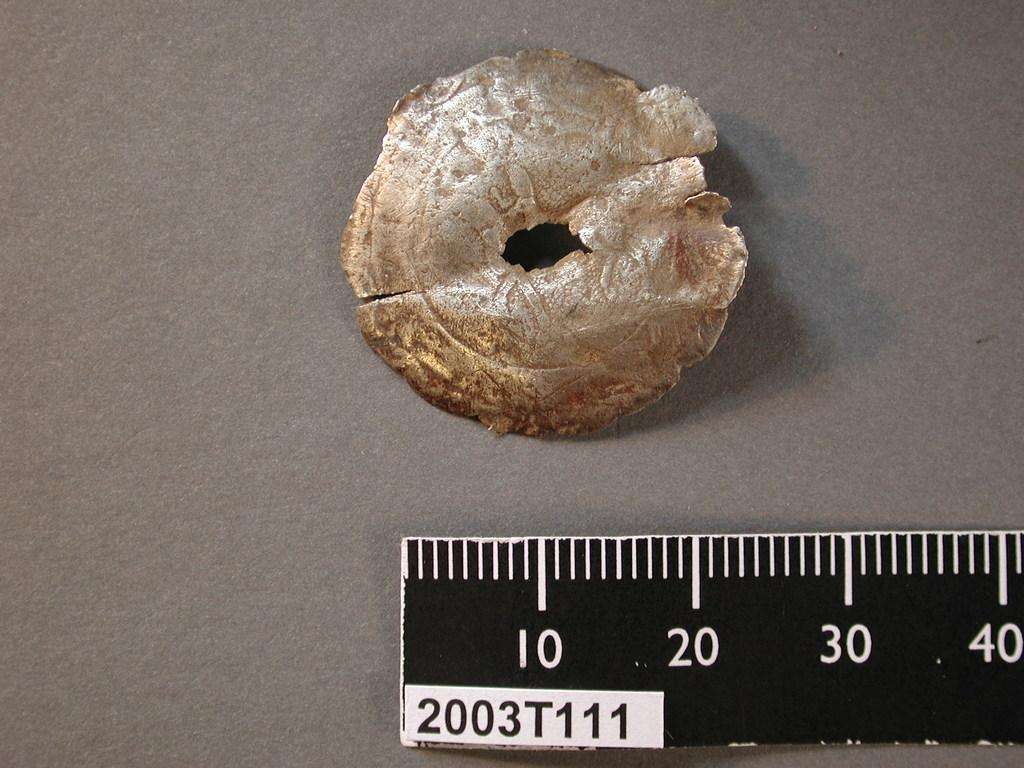<image>
Render a clear and concise summary of the photo. Granite Rock measuring about 23 Centimeters with a model number 2003 